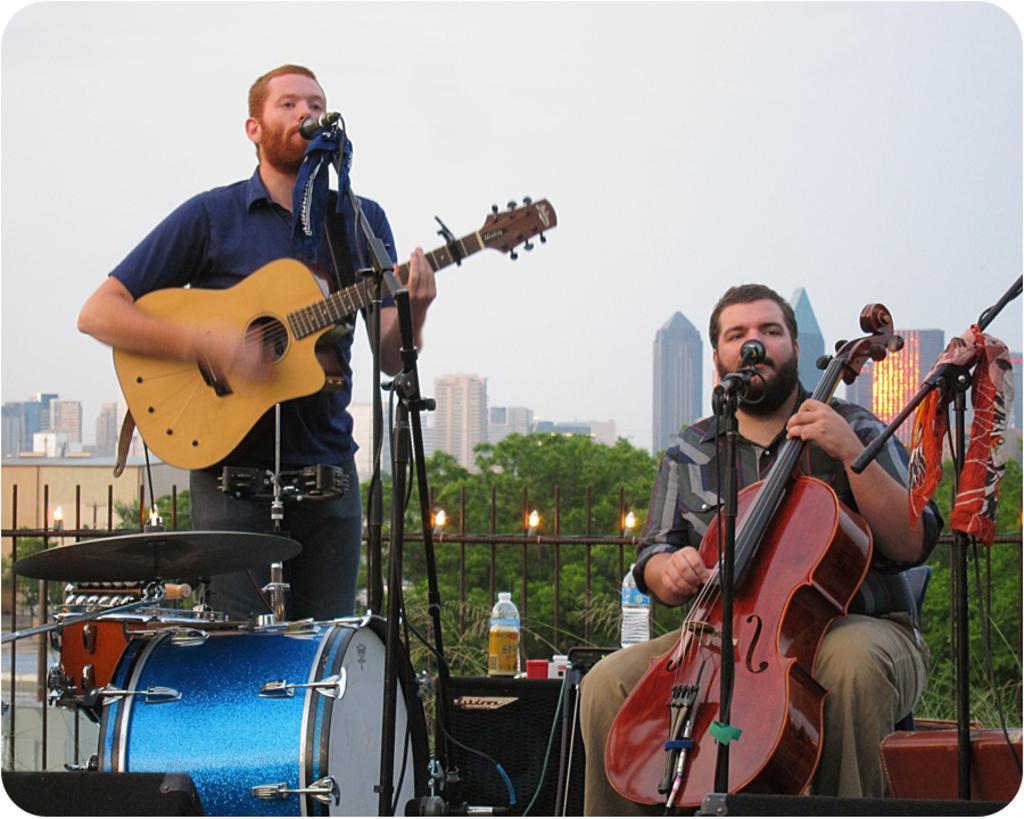Can you describe this image briefly? In this image i can see a person standing and holding a guitar in his hand and to the right there is another person sitting and holding a violin in his hand. There are microphones in front of them. In the background i can see buildings, trees, lights and the sky. 